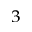Convert formula to latex. <formula><loc_0><loc_0><loc_500><loc_500>^ { 3 }</formula> 